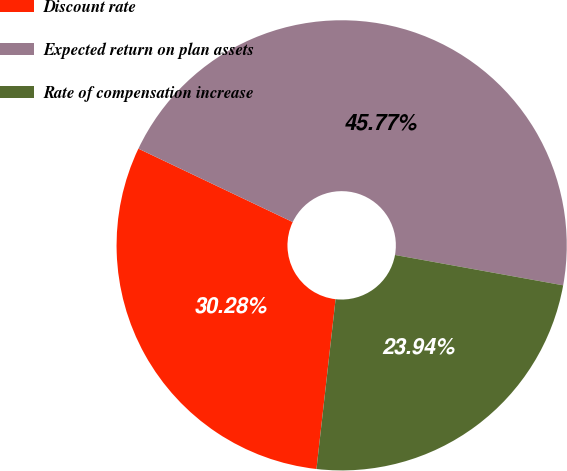<chart> <loc_0><loc_0><loc_500><loc_500><pie_chart><fcel>Discount rate<fcel>Expected return on plan assets<fcel>Rate of compensation increase<nl><fcel>30.28%<fcel>45.77%<fcel>23.94%<nl></chart> 